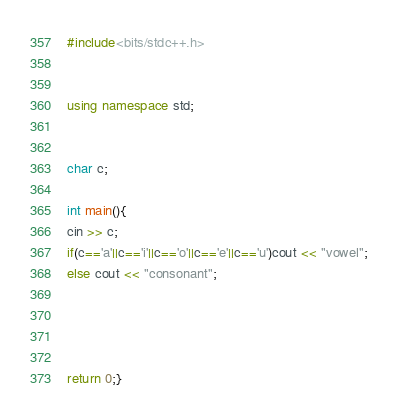<code> <loc_0><loc_0><loc_500><loc_500><_C++_>#include<bits/stdc++.h>


using namespace std;


char c;

int main(){
cin >> c;
if(c=='a'||c=='i'||c=='o'||c=='e'||c=='u')cout << "vowel";
else cout << "consonant";




return 0;}
</code> 